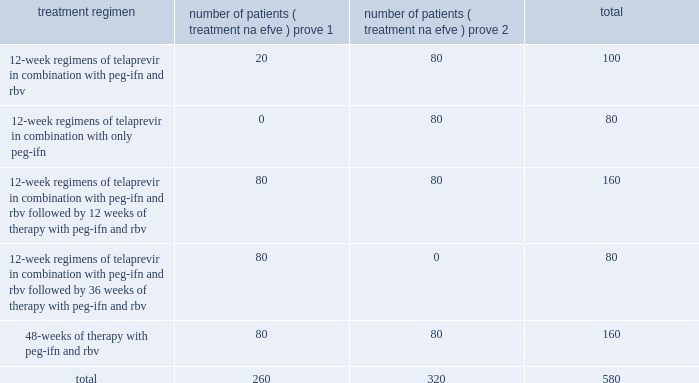United states , fail to either complete treatment or show a long-term sustained response to therapy .
As a result , we believe new safe and effective treatment options for hcv infection are needed .
Telaprevir development program we are conducting three major phase 2b clinical trials of telaprevir .
Prove 1 is ongoing in the united states and prove 2 is ongoing in european union , both in treatment-na efve patients .
Prove 3 has commenced and is being conducted with patients in north america and the european union who did not achieve sustained viral response with previous interferon-based treatments .
Prove 1 and prove 2 are fully enrolled , and we commenced patient enrollment in prove 3 in january 2007 .
Prove 1 and prove 2 we expect that together , the prove 1 and prove 2 clinical trials will evaluate rates of sustained viral response , or svr , in approximately 580 treatment-na efve patients infected with genotype 1 hcv , including patients who will receive telaprevir and patients in the control arms .
Svr is defined as undetectable viral levels 24 weeks after all treatment has ceased .
A description of each of the clinical trial arms for the prove 1 and prove 2 clinical trials , including the intended number of patients in each trial , is set forth in the table : the prove 1 and prove 2 clinical trials together have the following four key objectives : 2022 to evaluate the optimal svr rate that can be achieved with telaprevir therapy in combination with peg-ifn and rbv ; 2022 to evaluate the optimal treatment duration for telaprevir combination therapy ; 2022 to evaluate the role of rbv in telaprevir-based therapy ; and 2022 to evaluate the safety of telaprevir in combination with peg-ifn and rbv .
In the prove 1 and prove 2 clinical trials , patients receive telaprevir in a tablet formulation at a dose of 750 mg every eight hours for 12 weeks .
The prove 1 clinical trial is double-blinded and placebo-controlled , and the prove 2 clinical trial is partially-blinded and placebo-controlled .
In december 2006 , we announced results from a planned interim safety and antiviral activity analysis that was conducted and reviewed by the independent data monitoring committee overseeing the prove 1 clinical trial .
As of the cut-off date of the interim analysis , a total of 250 patients had been enrolled in the prove 1 clinical trial and received at least one dose of telaprevir or placebo .
In the data reported , the patients in all three telaprevir-containing arms ( approximately 175 patients ) were pooled together and the results were compared to the results in the control arm of peg-ifn and rbv and placebo ( approximately 75 patients ) .
At the time of the data cut-off for the safety analysis , approximately 100 patients had completed 12 weeks on-study and more than 200 patients had completed eight weeks .
The most common adverse treatment regimen number of patients ( treatment na efve ) prove 1 number of patients ( treatment na efve ) prove 2 total .

What was the percent of the total treatment regiment for prove1 for the 48-weeks of therapy with peg-ifn and rbv? 
Computations: (80 / 260)
Answer: 0.30769. 